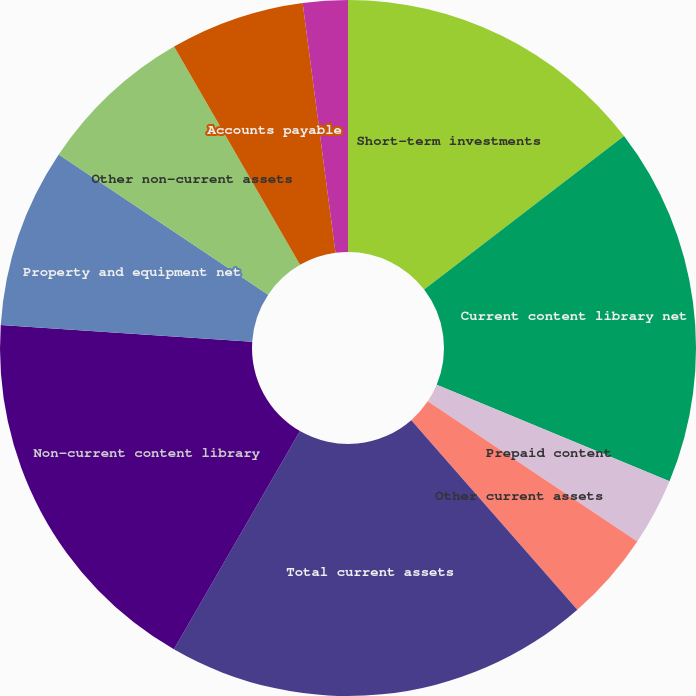<chart> <loc_0><loc_0><loc_500><loc_500><pie_chart><fcel>Short-term investments<fcel>Current content library net<fcel>Prepaid content<fcel>Other current assets<fcel>Total current assets<fcel>Non-current content library<fcel>Property and equipment net<fcel>Other non-current assets<fcel>Accounts payable<fcel>Accrued expenses<nl><fcel>14.58%<fcel>16.67%<fcel>3.13%<fcel>4.17%<fcel>19.79%<fcel>17.71%<fcel>8.33%<fcel>7.29%<fcel>6.25%<fcel>2.08%<nl></chart> 